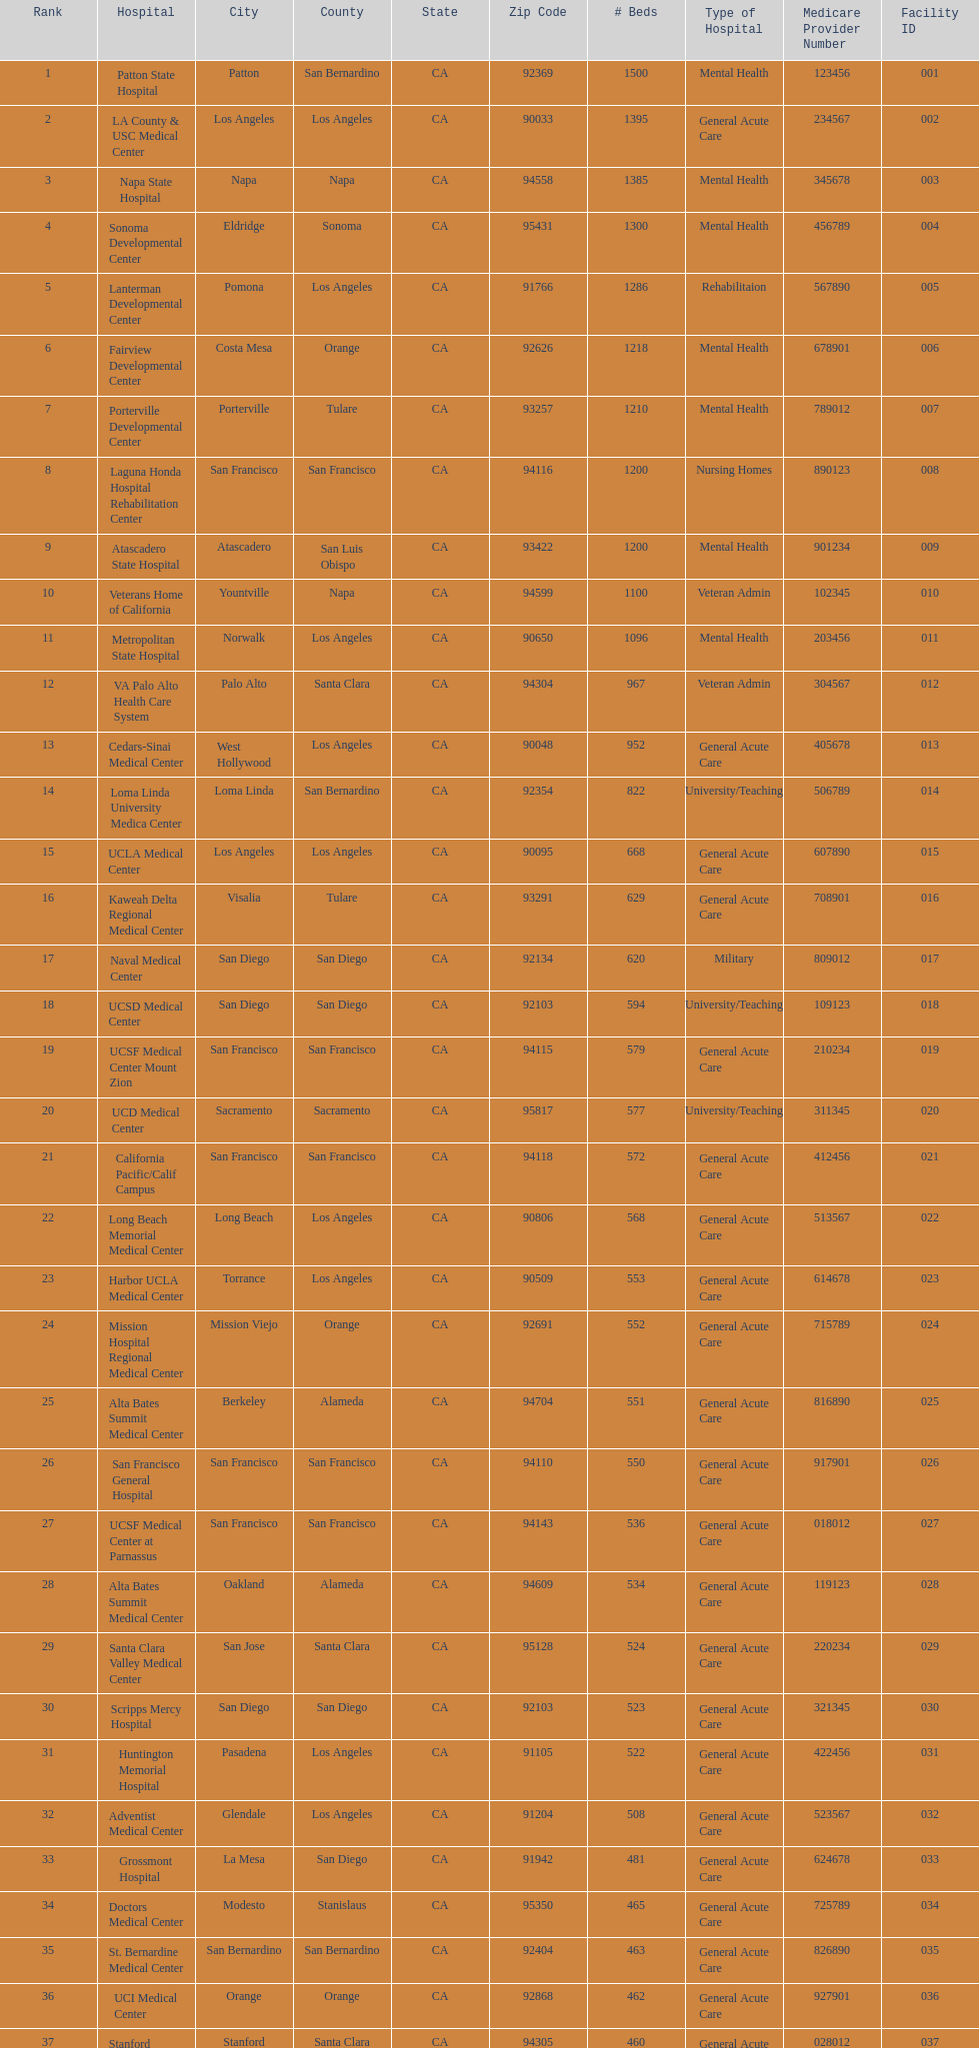Can you give me this table as a dict? {'header': ['Rank', 'Hospital', 'City', 'County', 'State', 'Zip Code', '# Beds', 'Type of Hospital', 'Medicare Provider Number', 'Facility ID'], 'rows': [['1', 'Patton State Hospital', 'Patton', 'San Bernardino', 'CA', '92369', '1500', 'Mental Health', '123456', '001'], ['2', 'LA County & USC Medical Center', 'Los Angeles', 'Los Angeles', 'CA', '90033', '1395', 'General Acute Care', '234567', '002'], ['3', 'Napa State Hospital', 'Napa', 'Napa', 'CA', '94558', '1385', 'Mental Health', '345678', '003'], ['4', 'Sonoma Developmental Center', 'Eldridge', 'Sonoma', 'CA', '95431', '1300', 'Mental Health', '456789', '004'], ['5', 'Lanterman Developmental Center', 'Pomona', 'Los Angeles', 'CA', '91766', '1286', 'Rehabilitaion', '567890', '005'], ['6', 'Fairview Developmental Center', 'Costa Mesa', 'Orange', 'CA', '92626', '1218', 'Mental Health', '678901', '006'], ['7', 'Porterville Developmental Center', 'Porterville', 'Tulare', 'CA', '93257', '1210', 'Mental Health', '789012', '007'], ['8', 'Laguna Honda Hospital Rehabilitation Center', 'San Francisco', 'San Francisco', 'CA', '94116', '1200', 'Nursing Homes', '890123', '008'], ['9', 'Atascadero State Hospital', 'Atascadero', 'San Luis Obispo', 'CA', '93422', '1200', 'Mental Health', '901234', '009'], ['10', 'Veterans Home of California', 'Yountville', 'Napa', 'CA', '94599', '1100', 'Veteran Admin', '102345', '010'], ['11', 'Metropolitan State Hospital', 'Norwalk', 'Los Angeles', 'CA', '90650', '1096', 'Mental Health', '203456', '011'], ['12', 'VA Palo Alto Health Care System', 'Palo Alto', 'Santa Clara', 'CA', '94304', '967', 'Veteran Admin', '304567', '012'], ['13', 'Cedars-Sinai Medical Center', 'West Hollywood', 'Los Angeles', 'CA', '90048', '952', 'General Acute Care', '405678', '013'], ['14', 'Loma Linda University Medica Center', 'Loma Linda', 'San Bernardino', 'CA', '92354', '822', 'University/Teaching', '506789', '014'], ['15', 'UCLA Medical Center', 'Los Angeles', 'Los Angeles', 'CA', '90095', '668', 'General Acute Care', '607890', '015'], ['16', 'Kaweah Delta Regional Medical Center', 'Visalia', 'Tulare', 'CA', '93291', '629', 'General Acute Care', '708901', '016'], ['17', 'Naval Medical Center', 'San Diego', 'San Diego', 'CA', '92134', '620', 'Military', '809012', '017'], ['18', 'UCSD Medical Center', 'San Diego', 'San Diego', 'CA', '92103', '594', 'University/Teaching', '109123', '018'], ['19', 'UCSF Medical Center Mount Zion', 'San Francisco', 'San Francisco', 'CA', '94115', '579', 'General Acute Care', '210234', '019'], ['20', 'UCD Medical Center', 'Sacramento', 'Sacramento', 'CA', '95817', '577', 'University/Teaching', '311345', '020'], ['21', 'California Pacific/Calif Campus', 'San Francisco', 'San Francisco', 'CA', '94118', '572', 'General Acute Care', '412456', '021'], ['22', 'Long Beach Memorial Medical Center', 'Long Beach', 'Los Angeles', 'CA', '90806', '568', 'General Acute Care', '513567', '022'], ['23', 'Harbor UCLA Medical Center', 'Torrance', 'Los Angeles', 'CA', '90509', '553', 'General Acute Care', '614678', '023'], ['24', 'Mission Hospital Regional Medical Center', 'Mission Viejo', 'Orange', 'CA', '92691', '552', 'General Acute Care', '715789', '024'], ['25', 'Alta Bates Summit Medical Center', 'Berkeley', 'Alameda', 'CA', '94704', '551', 'General Acute Care', '816890', '025'], ['26', 'San Francisco General Hospital', 'San Francisco', 'San Francisco', 'CA', '94110', '550', 'General Acute Care', '917901', '026'], ['27', 'UCSF Medical Center at Parnassus', 'San Francisco', 'San Francisco', 'CA', '94143', '536', 'General Acute Care', '018012', '027'], ['28', 'Alta Bates Summit Medical Center', 'Oakland', 'Alameda', 'CA', '94609', '534', 'General Acute Care', '119123', '028'], ['29', 'Santa Clara Valley Medical Center', 'San Jose', 'Santa Clara', 'CA', '95128', '524', 'General Acute Care', '220234', '029'], ['30', 'Scripps Mercy Hospital', 'San Diego', 'San Diego', 'CA', '92103', '523', 'General Acute Care', '321345', '030'], ['31', 'Huntington Memorial Hospital', 'Pasadena', 'Los Angeles', 'CA', '91105', '522', 'General Acute Care', '422456', '031'], ['32', 'Adventist Medical Center', 'Glendale', 'Los Angeles', 'CA', '91204', '508', 'General Acute Care', '523567', '032'], ['33', 'Grossmont Hospital', 'La Mesa', 'San Diego', 'CA', '91942', '481', 'General Acute Care', '624678', '033'], ['34', 'Doctors Medical Center', 'Modesto', 'Stanislaus', 'CA', '95350', '465', 'General Acute Care', '725789', '034'], ['35', 'St. Bernardine Medical Center', 'San Bernardino', 'San Bernardino', 'CA', '92404', '463', 'General Acute Care', '826890', '035'], ['36', 'UCI Medical Center', 'Orange', 'Orange', 'CA', '92868', '462', 'General Acute Care', '927901', '036'], ['37', 'Stanford Medical Center', 'Stanford', 'Santa Clara', 'CA', '94305', '460', 'General Acute Care', '028012', '037'], ['38', 'Community Regional Medical Center', 'Fresno', 'Fresno', 'CA', '93721', '457', 'General Acute Care', '129123', '038'], ['39', 'Methodist Hospital', 'Arcadia', 'Los Angeles', 'CA', '91007', '455', 'General Acute Care', '230234', '039'], ['40', 'Providence St. Joseph Medical Center', 'Burbank', 'Los Angeles', 'CA', '91505', '455', 'General Acute Care', '331345', '040'], ['41', 'Hoag Memorial Hospital', 'Newport Beach', 'Orange', 'CA', '92663', '450', 'General Acute Care', '432456', '041'], ['42', 'Agnews Developmental Center', 'San Jose', 'Santa Clara', 'CA', '95134', '450', 'Mental Health', '533567', '042'], ['43', 'Jewish Home', 'San Francisco', 'San Francisco', 'CA', '94112', '450', 'Nursing Homes', '634678', '043'], ['44', 'St. Joseph Hospital Orange', 'Orange', 'Orange', 'CA', '92868', '448', 'General Acute Care', '735789', '044'], ['45', 'Presbyterian Intercommunity', 'Whittier', 'Los Angeles', 'CA', '90602', '441', 'General Acute Care', '836890', '045'], ['46', 'Kaiser Permanente Medical Center', 'Fontana', 'San Bernardino', 'CA', '92335', '440', 'General Acute Care', '937901', '046'], ['47', 'Kaiser Permanente Medical Center', 'Los Angeles', 'Los Angeles', 'CA', '90027', '439', 'General Acute Care', '038012', '047'], ['48', 'Pomona Valley Hospital Medical Center', 'Pomona', 'Los Angeles', 'CA', '91767', '436', 'General Acute Care', '139123', '048'], ['49', 'Sutter General Medical Center', 'Sacramento', 'Sacramento', 'CA', '95819', '432', 'General Acute Care', '240234', '049'], ['50', 'St. Mary Medical Center', 'San Francisco', 'San Francisco', 'CA', '94114', '430', 'General Acute Care', '341345', '050'], ['50', 'Good Samaritan Hospital', 'San Jose', 'Santa Clara', 'CA', '95124', '429', 'General Acute Care', '442456', '051']]} How many hospitals have at least 1,000 beds? 11. 